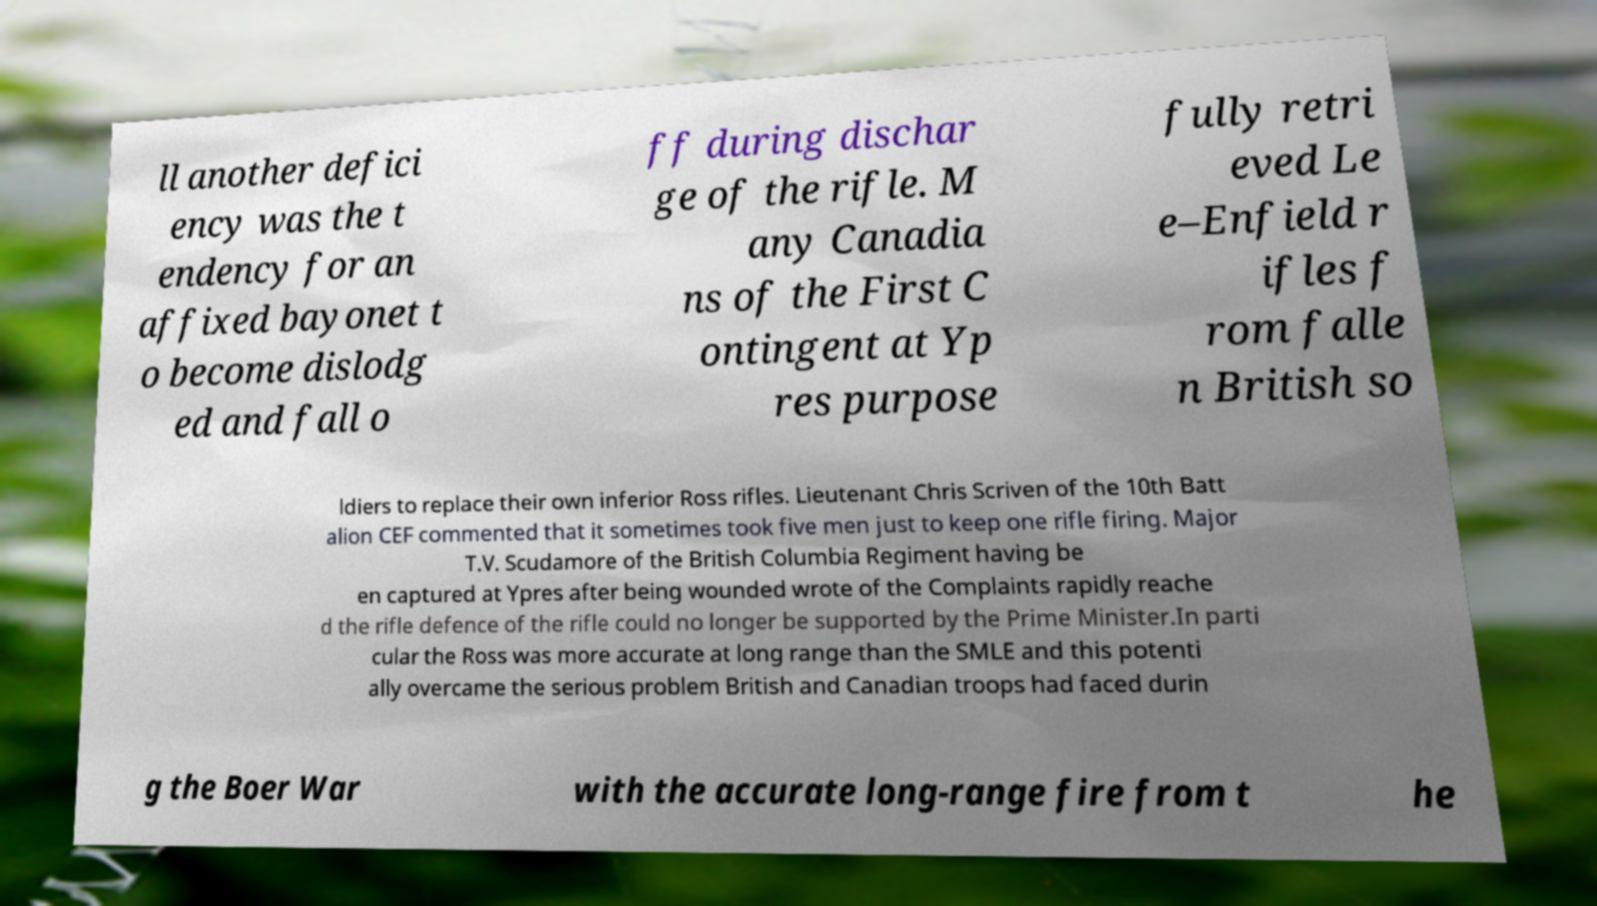Could you extract and type out the text from this image? ll another defici ency was the t endency for an affixed bayonet t o become dislodg ed and fall o ff during dischar ge of the rifle. M any Canadia ns of the First C ontingent at Yp res purpose fully retri eved Le e–Enfield r ifles f rom falle n British so ldiers to replace their own inferior Ross rifles. Lieutenant Chris Scriven of the 10th Batt alion CEF commented that it sometimes took five men just to keep one rifle firing. Major T.V. Scudamore of the British Columbia Regiment having be en captured at Ypres after being wounded wrote of the Complaints rapidly reache d the rifle defence of the rifle could no longer be supported by the Prime Minister.In parti cular the Ross was more accurate at long range than the SMLE and this potenti ally overcame the serious problem British and Canadian troops had faced durin g the Boer War with the accurate long-range fire from t he 